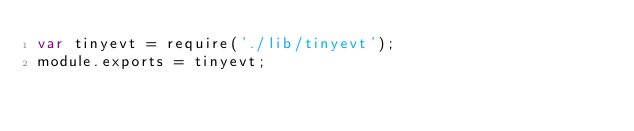<code> <loc_0><loc_0><loc_500><loc_500><_JavaScript_>var tinyevt = require('./lib/tinyevt');
module.exports = tinyevt;</code> 